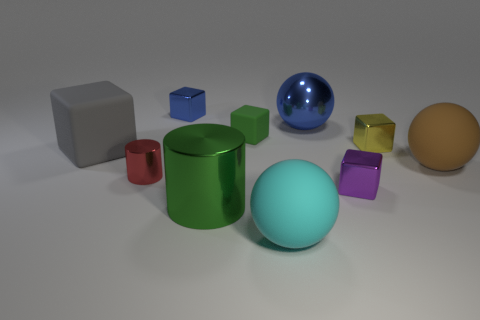Is there anything else that is the same material as the big cyan thing?
Offer a very short reply. Yes. Is there a blue thing of the same shape as the big gray rubber object?
Your answer should be very brief. Yes. Do the tiny rubber cube and the big metallic cylinder have the same color?
Make the answer very short. Yes. How big is the brown ball?
Ensure brevity in your answer.  Large. What is the size of the green thing behind the small purple block?
Offer a very short reply. Small. What shape is the thing that is the same color as the large metal ball?
Give a very brief answer. Cube. Do the tiny green cube and the blue thing behind the metallic sphere have the same material?
Keep it short and to the point. No. How many large blue metal objects are to the right of the metal cylinder right of the small blue shiny object behind the tiny purple block?
Your answer should be very brief. 1. How many yellow things are either spheres or large rubber spheres?
Offer a terse response. 0. There is a matte thing left of the blue shiny block; what shape is it?
Your answer should be compact. Cube. 